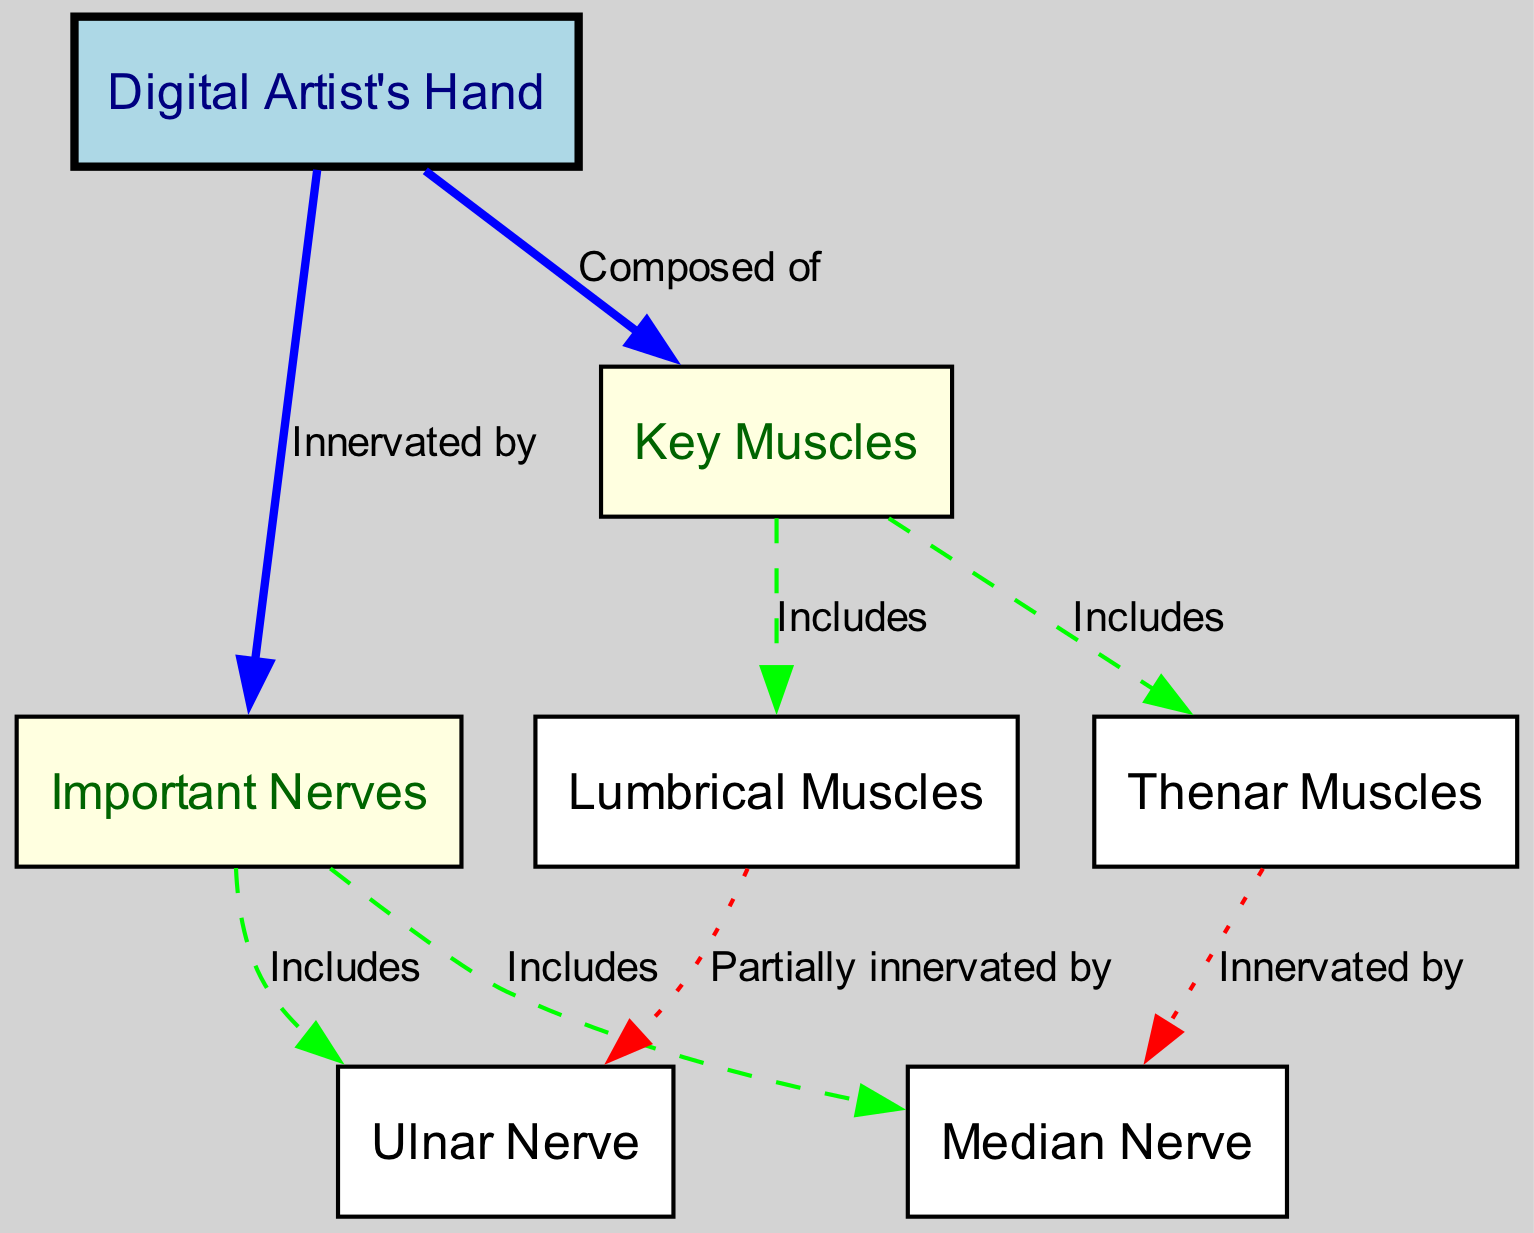What are the two main components of the digital artist's hand? The diagram shows two main components, indicated by the nodes "muscles" and "nerves" connected to the "Digital Artist's Hand" node.
Answer: muscles and nerves How many key muscles are included in the diagram? The diagram identifies two key muscles that are included within the "muscles" node: "Thenar Muscles" and "Lumbrical Muscles."
Answer: 2 Which nerve is associated with the thenar muscles? The arrow from the "thenar" node to the "median" node indicates that the thenar muscles are innervated by the median nerve.
Answer: Median Nerve What type of connection exists between the lumbrical muscles and the ulnar nerve? The relationship between the "lumbrical" node and the "ulnar" node is described by a label stating "Partially innervated by," indicating a more complex relationship than direct innervation.
Answer: Partially innervated by What color represents the digital artist's hand in the diagram? The node for the "Digital Artist's Hand" is filled with light blue color, distinguishing it from other nodes in the diagram.
Answer: Light blue 